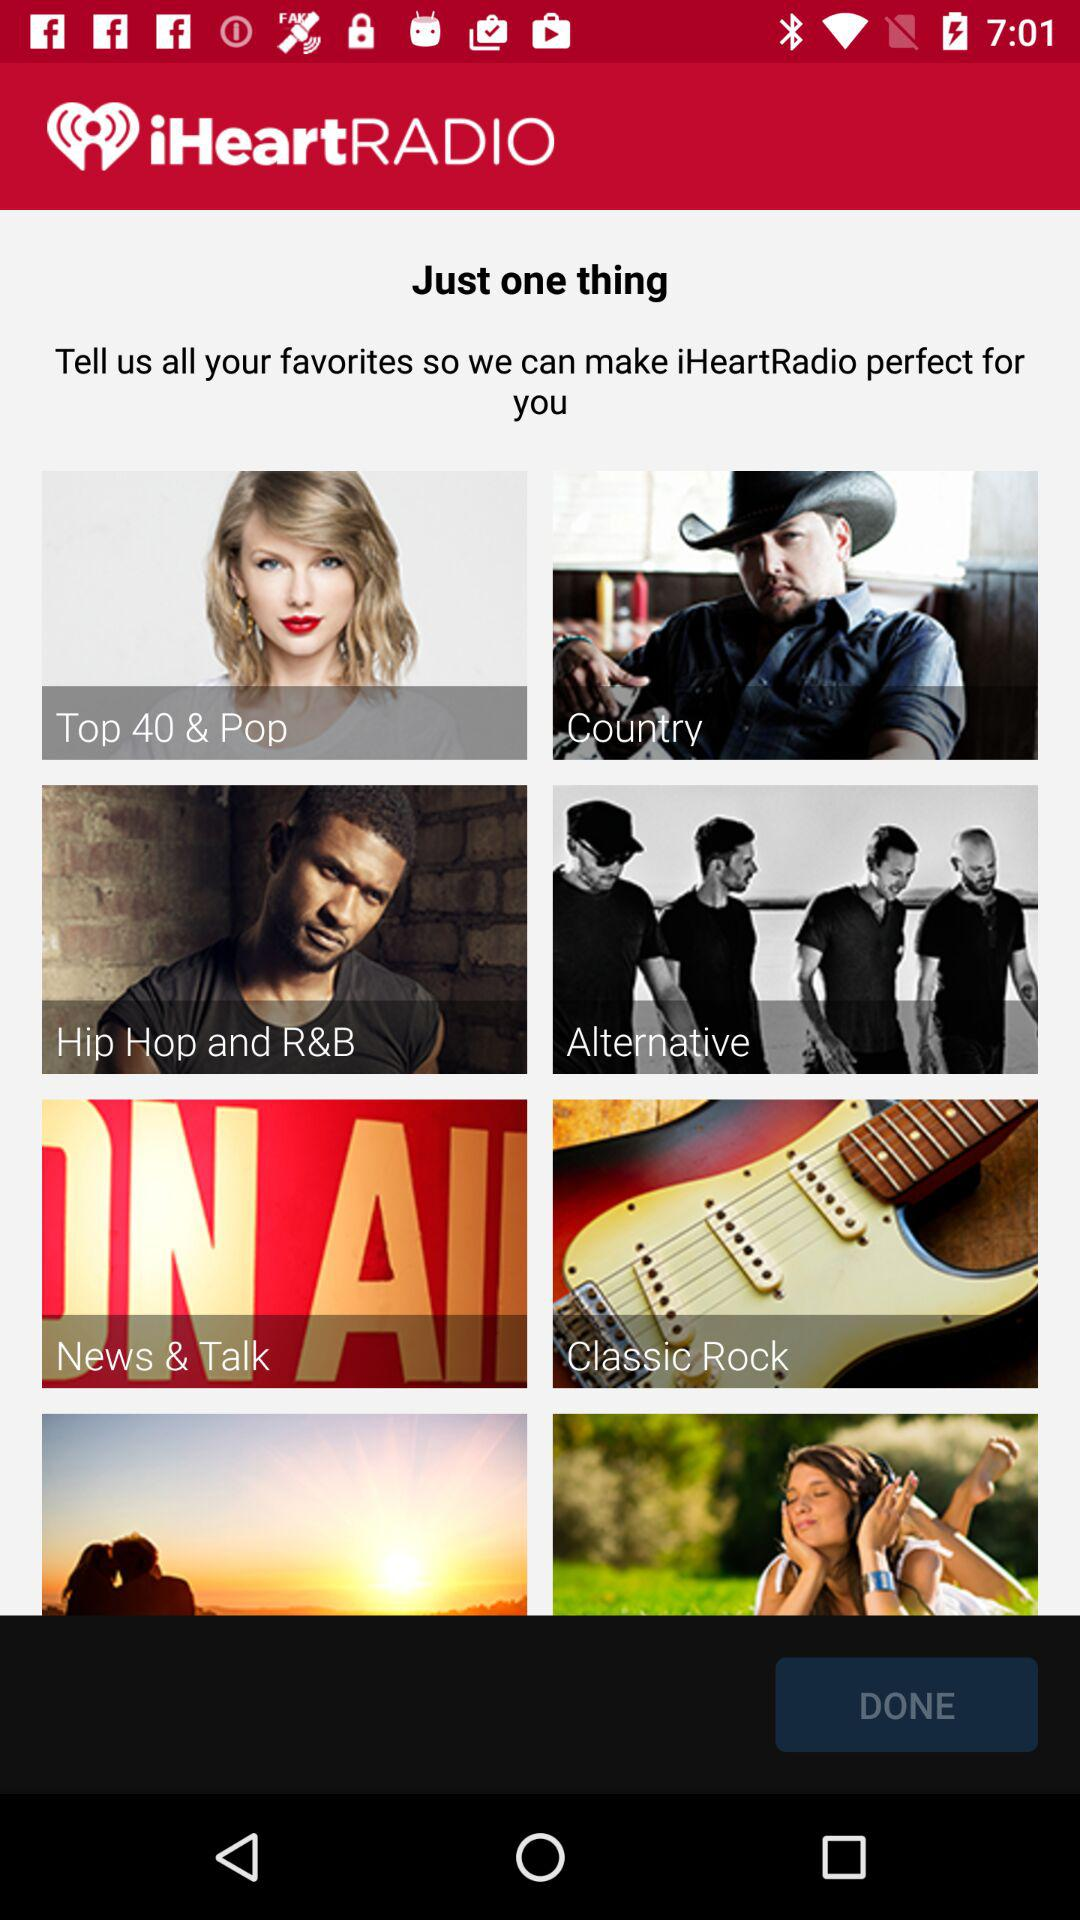What do we need to do to make iHeartRadio perfect for us? Tell us all your favorites to make iHeartRadio perfect for you. 